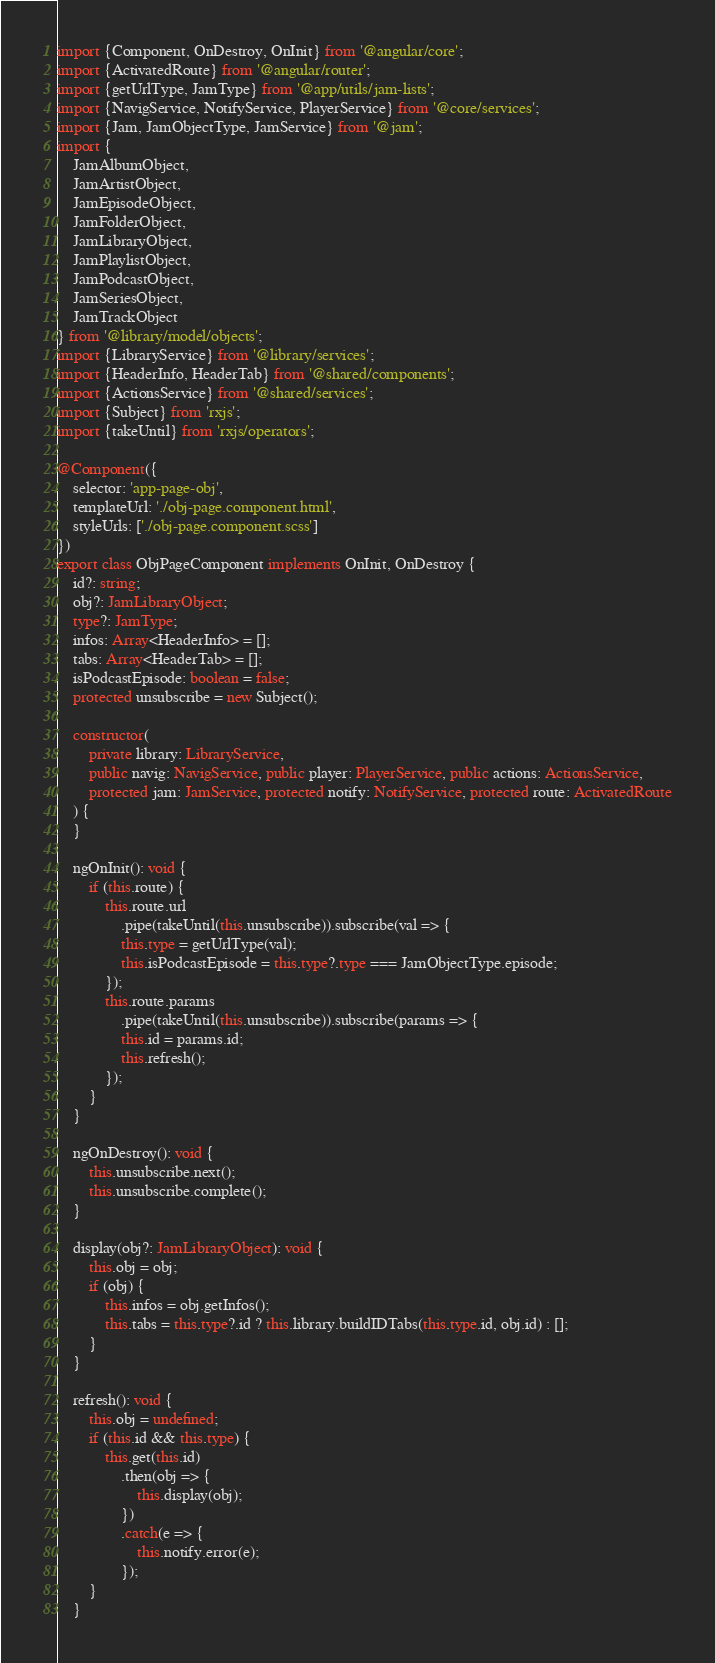Convert code to text. <code><loc_0><loc_0><loc_500><loc_500><_TypeScript_>import {Component, OnDestroy, OnInit} from '@angular/core';
import {ActivatedRoute} from '@angular/router';
import {getUrlType, JamType} from '@app/utils/jam-lists';
import {NavigService, NotifyService, PlayerService} from '@core/services';
import {Jam, JamObjectType, JamService} from '@jam';
import {
	JamAlbumObject,
	JamArtistObject,
	JamEpisodeObject,
	JamFolderObject,
	JamLibraryObject,
	JamPlaylistObject,
	JamPodcastObject,
	JamSeriesObject,
	JamTrackObject
} from '@library/model/objects';
import {LibraryService} from '@library/services';
import {HeaderInfo, HeaderTab} from '@shared/components';
import {ActionsService} from '@shared/services';
import {Subject} from 'rxjs';
import {takeUntil} from 'rxjs/operators';

@Component({
	selector: 'app-page-obj',
	templateUrl: './obj-page.component.html',
	styleUrls: ['./obj-page.component.scss']
})
export class ObjPageComponent implements OnInit, OnDestroy {
	id?: string;
	obj?: JamLibraryObject;
	type?: JamType;
	infos: Array<HeaderInfo> = [];
	tabs: Array<HeaderTab> = [];
	isPodcastEpisode: boolean = false;
	protected unsubscribe = new Subject();

	constructor(
		private library: LibraryService,
		public navig: NavigService, public player: PlayerService, public actions: ActionsService,
		protected jam: JamService, protected notify: NotifyService, protected route: ActivatedRoute
	) {
	}

	ngOnInit(): void {
		if (this.route) {
			this.route.url
				.pipe(takeUntil(this.unsubscribe)).subscribe(val => {
				this.type = getUrlType(val);
				this.isPodcastEpisode = this.type?.type === JamObjectType.episode;
			});
			this.route.params
				.pipe(takeUntil(this.unsubscribe)).subscribe(params => {
				this.id = params.id;
				this.refresh();
			});
		}
	}

	ngOnDestroy(): void {
		this.unsubscribe.next();
		this.unsubscribe.complete();
	}

	display(obj?: JamLibraryObject): void {
		this.obj = obj;
		if (obj) {
			this.infos = obj.getInfos();
			this.tabs = this.type?.id ? this.library.buildIDTabs(this.type.id, obj.id) : [];
		}
	}

	refresh(): void {
		this.obj = undefined;
		if (this.id && this.type) {
			this.get(this.id)
				.then(obj => {
					this.display(obj);
				})
				.catch(e => {
					this.notify.error(e);
				});
		}
	}
</code> 